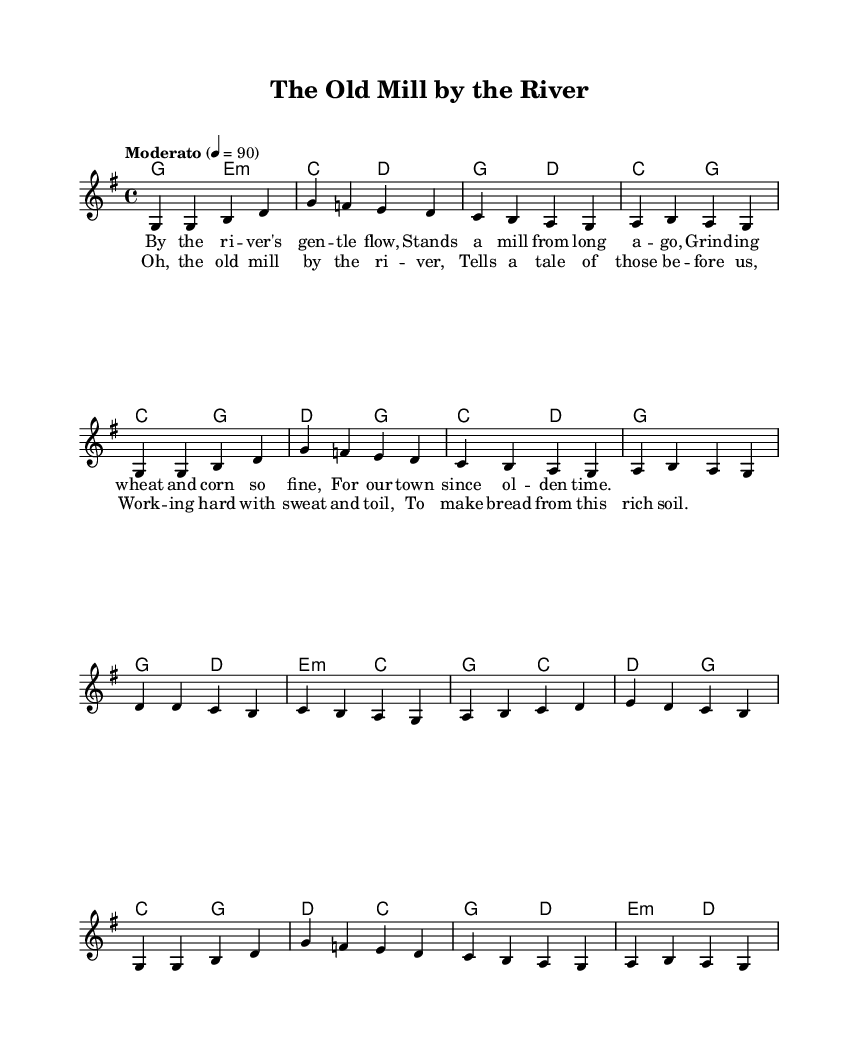What is the key signature of this music? The key signature is shown at the beginning of the staff; in this case, it indicates G major, which has one sharp (F#).
Answer: G major What is the time signature of this music? The time signature is indicated at the beginning of the score; this piece is in 4/4 time, meaning there are four beats per measure.
Answer: 4/4 What is the tempo marking for this piece? The tempo marking is located at the beginning and shows "Moderato" with a metronome indication of quarter note equals 90, which indicates a moderate speed.
Answer: Moderato How many measures are in the verse? Counting the measures in the verse section of the score indicates there are four measures of music in the verse lyrics.
Answer: Four What chord follows the opening melody notes in the first measure? The first chord indicated in the chord section at the beginning corresponds to the first measure's melody notes. Here, it is a G major chord.
Answer: G major Describe a theme from the lyrics of this song. By analyzing the lyrical content, the theme revolves around a historical mill by a river, symbolizing community heritage and hard work, reflective of folksy storytelling.
Answer: Community heritage What is the character of the chorus in terms of storytelling? The chorus emphasizes reflection and appreciation for the past and the contributions of earlier generations, thus reinforcing a sense of local history and cultural pride.
Answer: Reflection on local history 